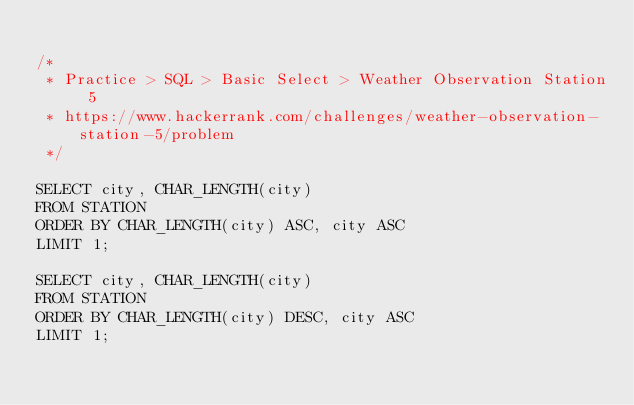<code> <loc_0><loc_0><loc_500><loc_500><_SQL_>
/*
 * Practice > SQL > Basic Select > Weather Observation Station 5
 * https://www.hackerrank.com/challenges/weather-observation-station-5/problem
 */

SELECT city, CHAR_LENGTH(city)
FROM STATION
ORDER BY CHAR_LENGTH(city) ASC, city ASC
LIMIT 1;

SELECT city, CHAR_LENGTH(city)
FROM STATION
ORDER BY CHAR_LENGTH(city) DESC, city ASC
LIMIT 1;
</code> 